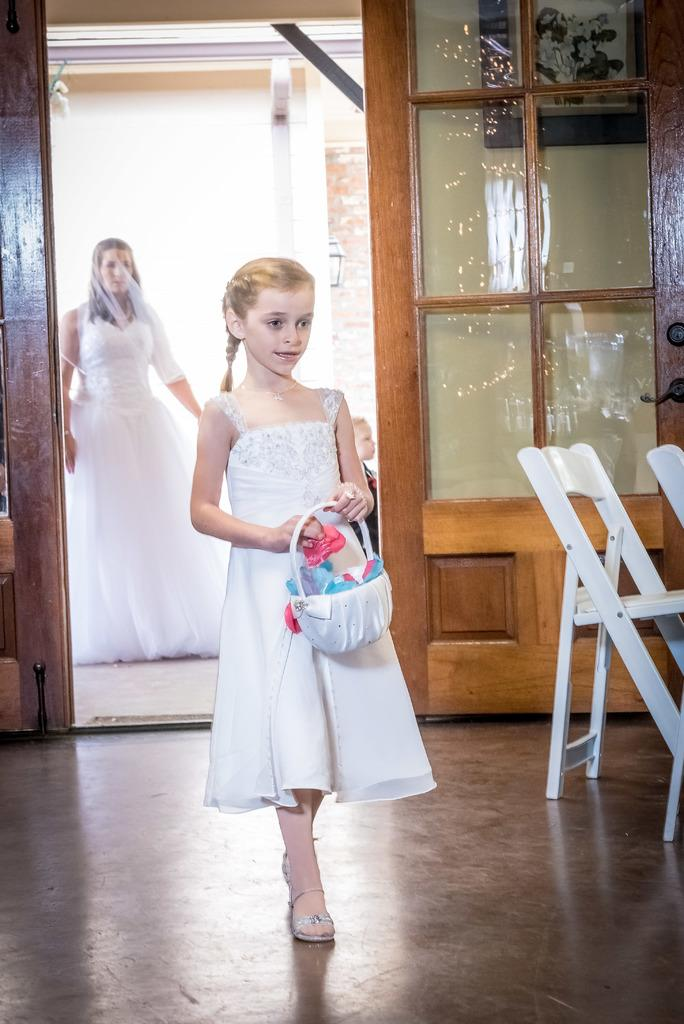What is the girl in the image holding? The girl in the image is holding a basket. Can you describe the people in the background of the image? There is a woman and a boy in the background of the image. What type of architectural feature is present in the background? There is a glass door in the background of the image. What type of furniture can be seen in the background? There are chairs in the background of the image. How does the girl kick the ball in the image? There is no ball present in the image, so the girl cannot kick a ball. 